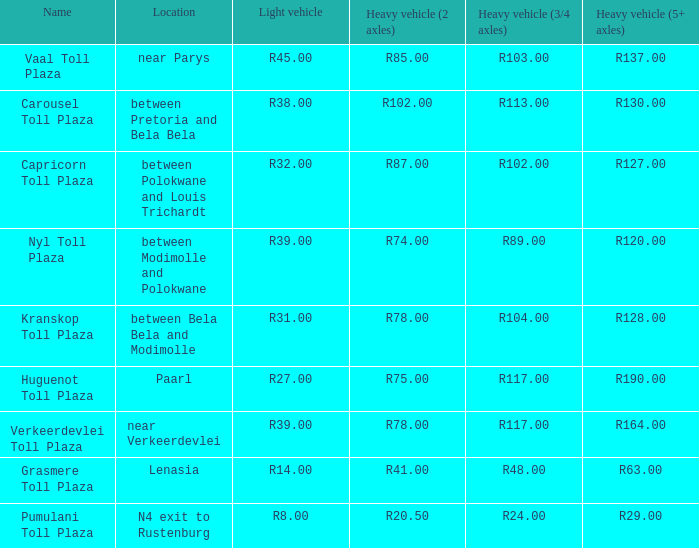What is the toll for heavy vehicles with 3/4 axles at Verkeerdevlei toll plaza? R117.00. 